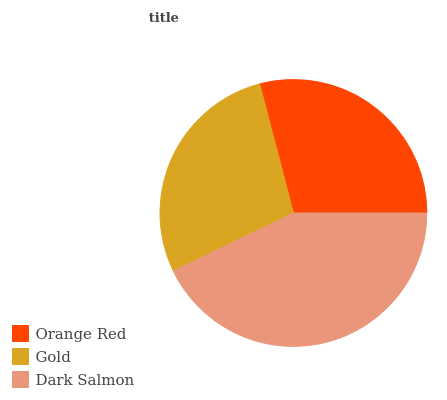Is Gold the minimum?
Answer yes or no. Yes. Is Dark Salmon the maximum?
Answer yes or no. Yes. Is Dark Salmon the minimum?
Answer yes or no. No. Is Gold the maximum?
Answer yes or no. No. Is Dark Salmon greater than Gold?
Answer yes or no. Yes. Is Gold less than Dark Salmon?
Answer yes or no. Yes. Is Gold greater than Dark Salmon?
Answer yes or no. No. Is Dark Salmon less than Gold?
Answer yes or no. No. Is Orange Red the high median?
Answer yes or no. Yes. Is Orange Red the low median?
Answer yes or no. Yes. Is Dark Salmon the high median?
Answer yes or no. No. Is Dark Salmon the low median?
Answer yes or no. No. 